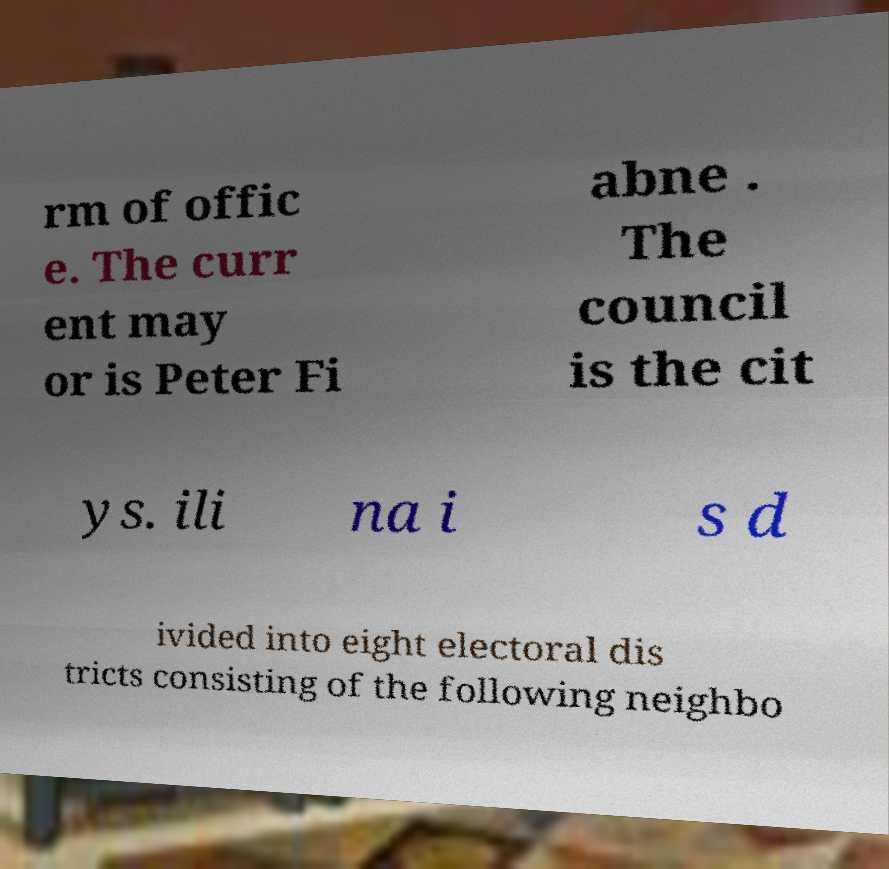There's text embedded in this image that I need extracted. Can you transcribe it verbatim? rm of offic e. The curr ent may or is Peter Fi abne . The council is the cit ys. ili na i s d ivided into eight electoral dis tricts consisting of the following neighbo 